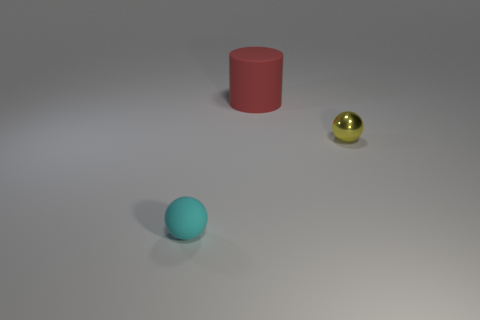Subtract all green cylinders. Subtract all yellow blocks. How many cylinders are left? 1 Add 1 tiny metal things. How many objects exist? 4 Subtract all balls. How many objects are left? 1 Add 3 balls. How many balls exist? 5 Subtract 0 yellow cylinders. How many objects are left? 3 Subtract all tiny purple metal objects. Subtract all large red rubber objects. How many objects are left? 2 Add 1 big red matte things. How many big red matte things are left? 2 